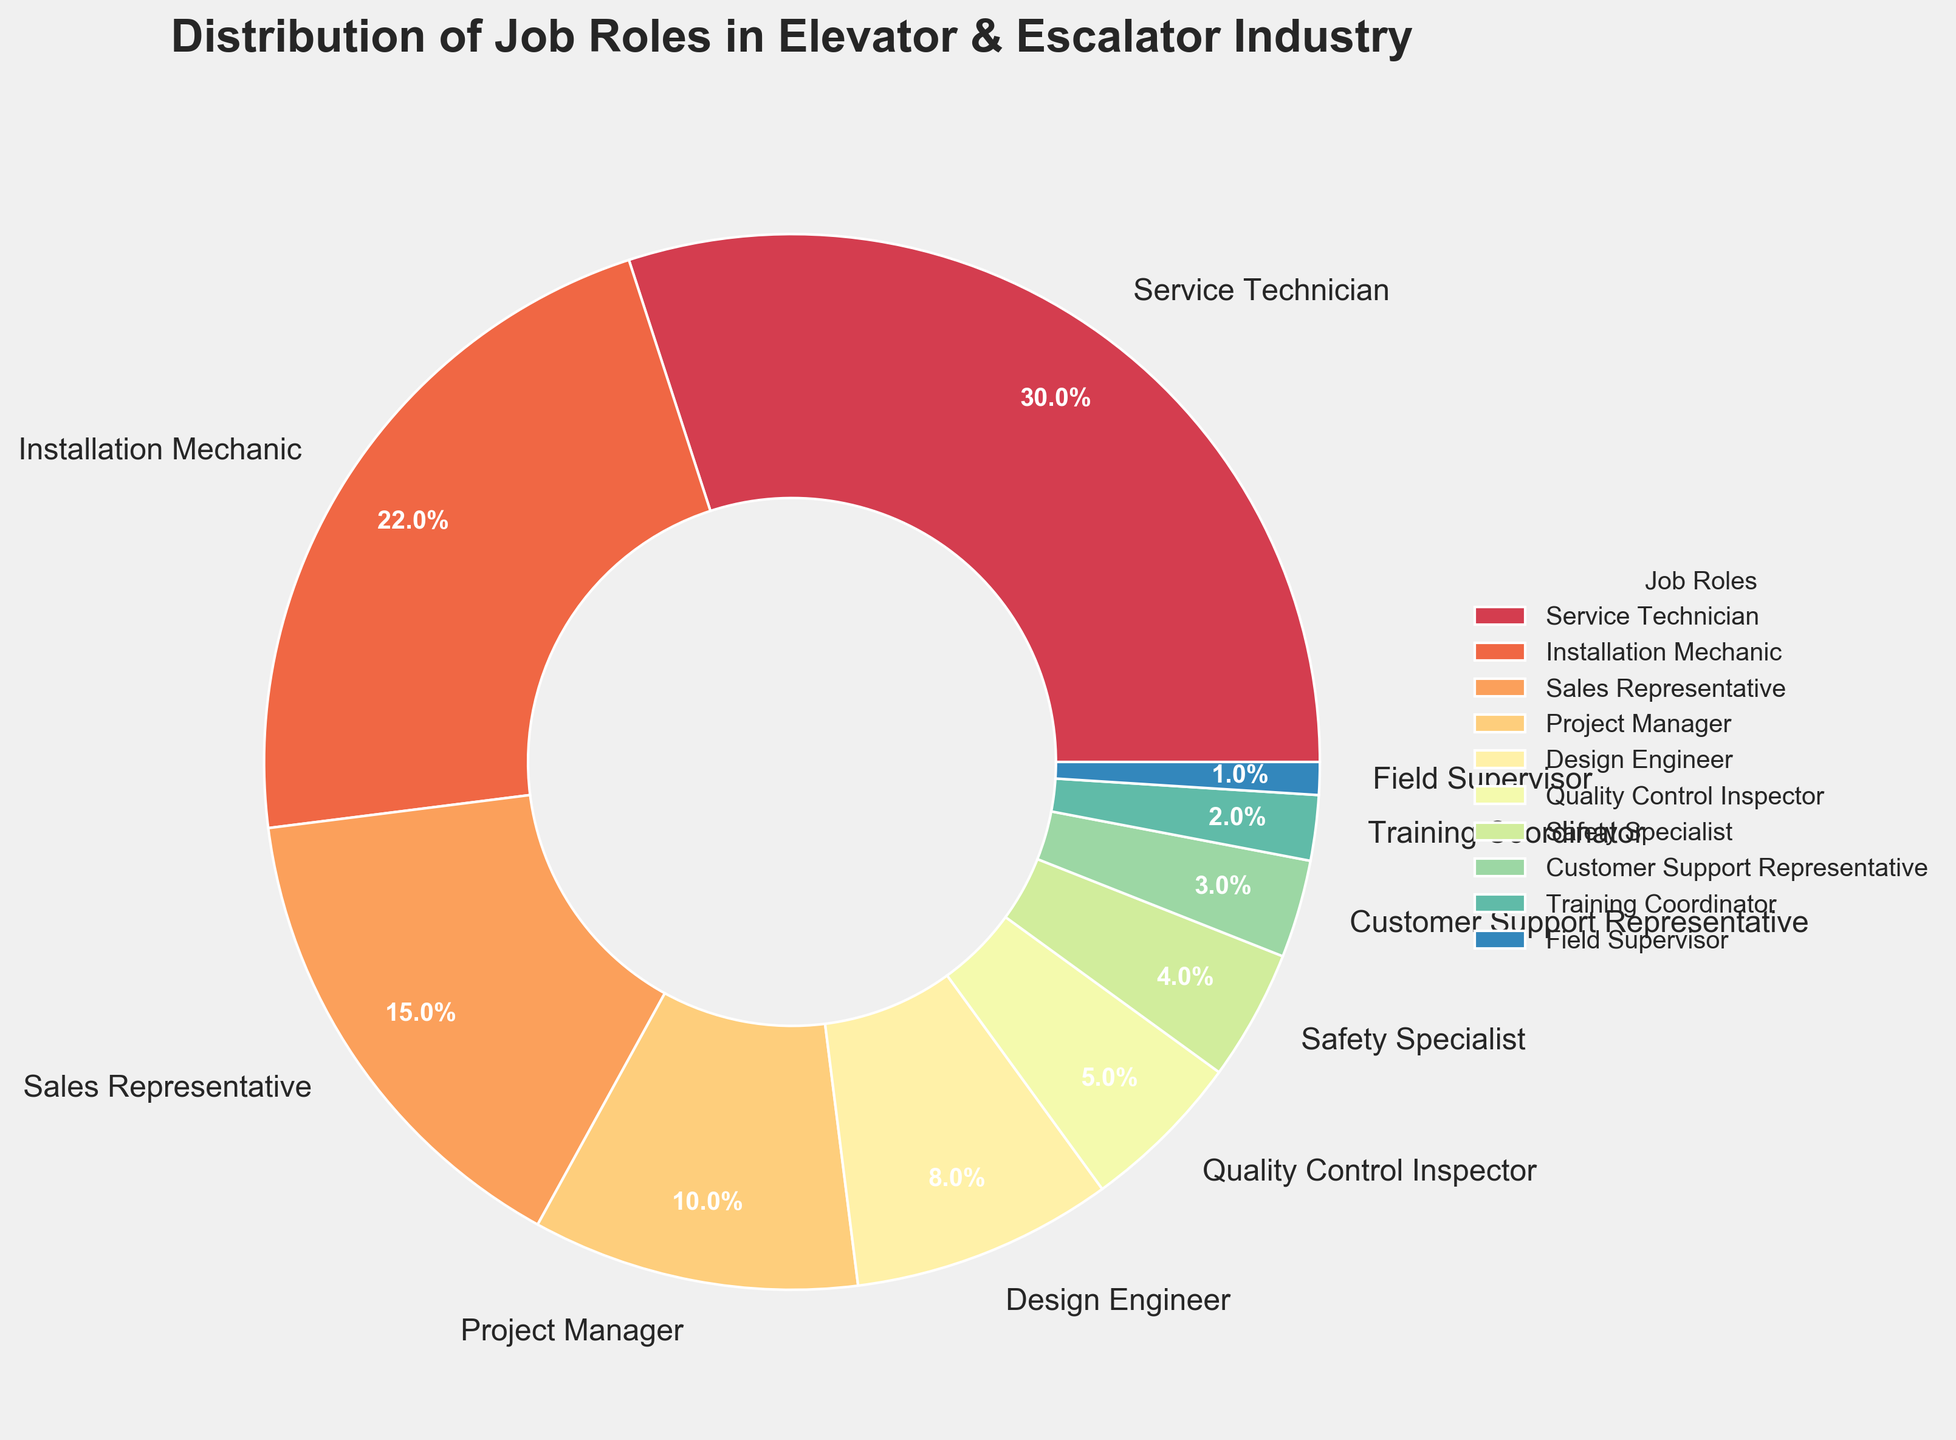Which job role has the highest percentage in the elevator and escalator industry? By looking at the pie chart, the Service Technician section is the largest, indicating it has the highest percentage.
Answer: Service Technician Which three job roles together form exactly half of the total distribution? Adding the percentages of Service Technician (30%), Installation Mechanic (22%), and Sales Representative (15%) yields 67%, while the combined percentage of Project Manager (10%), Design Engineer (8%), and Quality Control Inspector (5%) gives 23%. Thus, the combined percentage comes from Project Manager, Design Engineer, and Quality Control Inspector.
Answer: Service Technician, Installation Mechanic, and Sales Representative How many job roles constitute less than 10% each of the distribution? Identifying the segments representing less than 10%: Safety Specialist (4%), Customer Support Representative (3%), Training Coordinator (2%), and Field Supervisor (1%). Counting these segments, we get 4 roles.
Answer: 4 By how much does the percentage of Service Technicians exceed that of Installation Mechanics? Service Technicians make up 30% of the distribution, while Installation Mechanics make up 22%. The difference between these percentages is 30% - 22% = 8%.
Answer: 8% Which job role has the smallest representation, and what is its percentage? By examining the smallest segment of the pie chart, we see that the Field Supervisor has the smallest representation of 1%.
Answer: Field Supervisor, 1% Are there more Quality Control Inspectors or Installation Mechanics, and by how much? Quality Control Inspectors make up 5% of the distribution, while Installation Mechanics account for 22%. The difference is 22% - 5% = 17%.
Answer: Installation Mechanics by 17% What is the combined percentage of the roles related to safety and quality (Quality Control Inspector and Safety Specialist)? Adding the percentages of Quality Control Inspector (5%) and Safety Specialist (4%) gives 5% + 4% = 9%.
Answer: 9% How does the proportion of Sales Representatives compare to that of Project Managers? Sales Representatives make up 15% of the distribution, whereas Project Managers account for 10%. Thus, Sales Representatives have a 5% larger share than Project Managers.
Answer: Sales Representatives have 5% more Which job roles make up less than 5% of the industry? Identifying the segments that represent less than 5%: Safety Specialist (4%), Customer Support Representative (3%), Training Coordinator (2%), and Field Supervisor (1%).
Answer: Safety Specialist, Customer Support Representative, Training Coordinator, Field Supervisor 